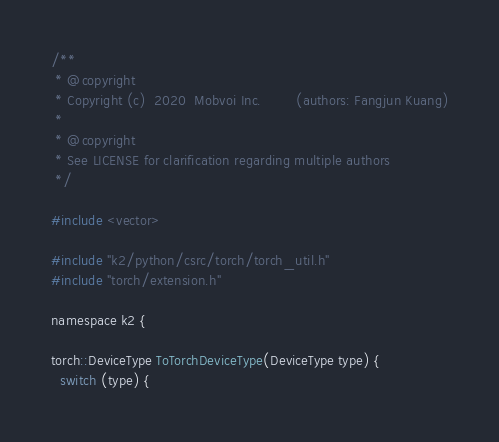<code> <loc_0><loc_0><loc_500><loc_500><_Cuda_>/**
 * @copyright
 * Copyright (c)  2020  Mobvoi Inc.        (authors: Fangjun Kuang)
 *
 * @copyright
 * See LICENSE for clarification regarding multiple authors
 */

#include <vector>

#include "k2/python/csrc/torch/torch_util.h"
#include "torch/extension.h"

namespace k2 {

torch::DeviceType ToTorchDeviceType(DeviceType type) {
  switch (type) {</code> 